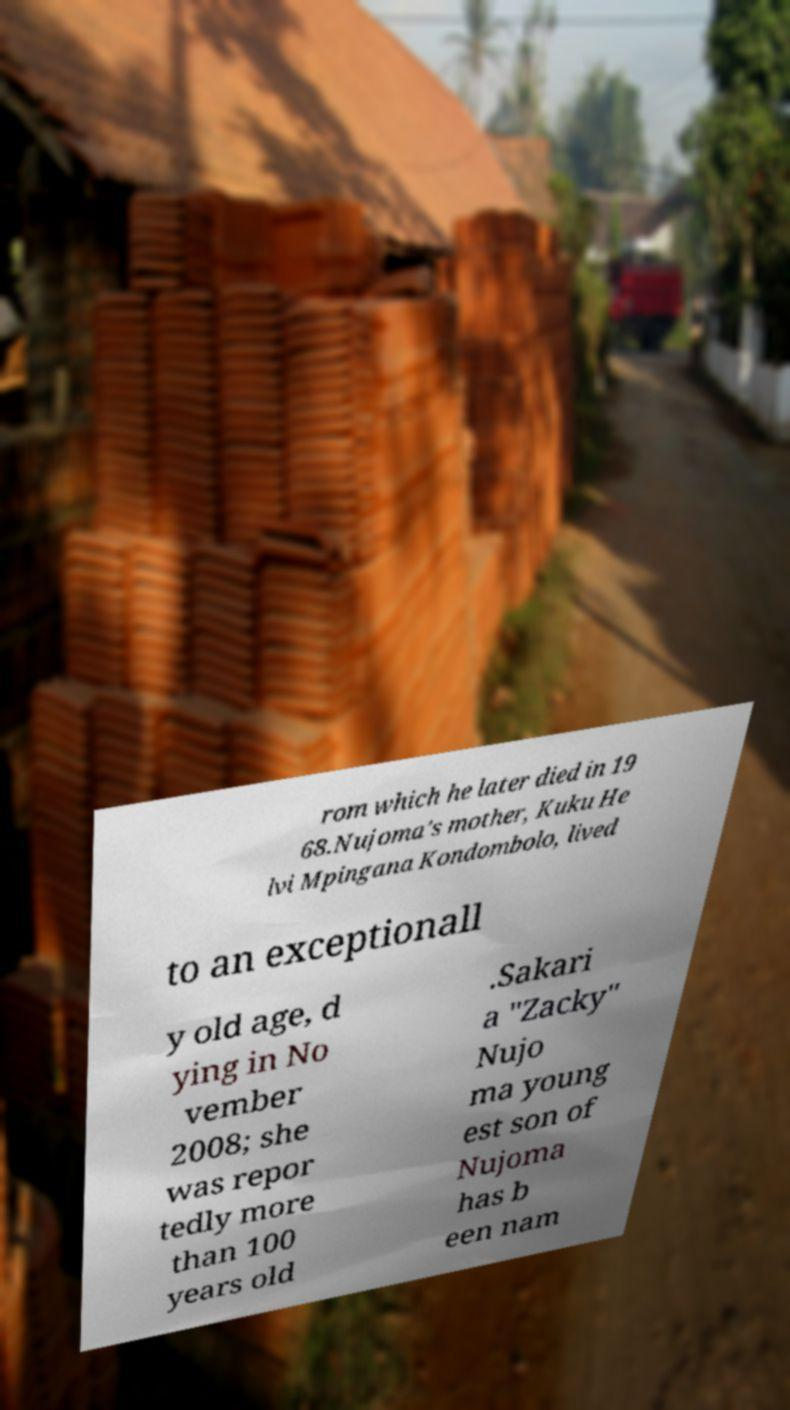Can you accurately transcribe the text from the provided image for me? rom which he later died in 19 68.Nujoma's mother, Kuku He lvi Mpingana Kondombolo, lived to an exceptionall y old age, d ying in No vember 2008; she was repor tedly more than 100 years old .Sakari a "Zacky" Nujo ma young est son of Nujoma has b een nam 